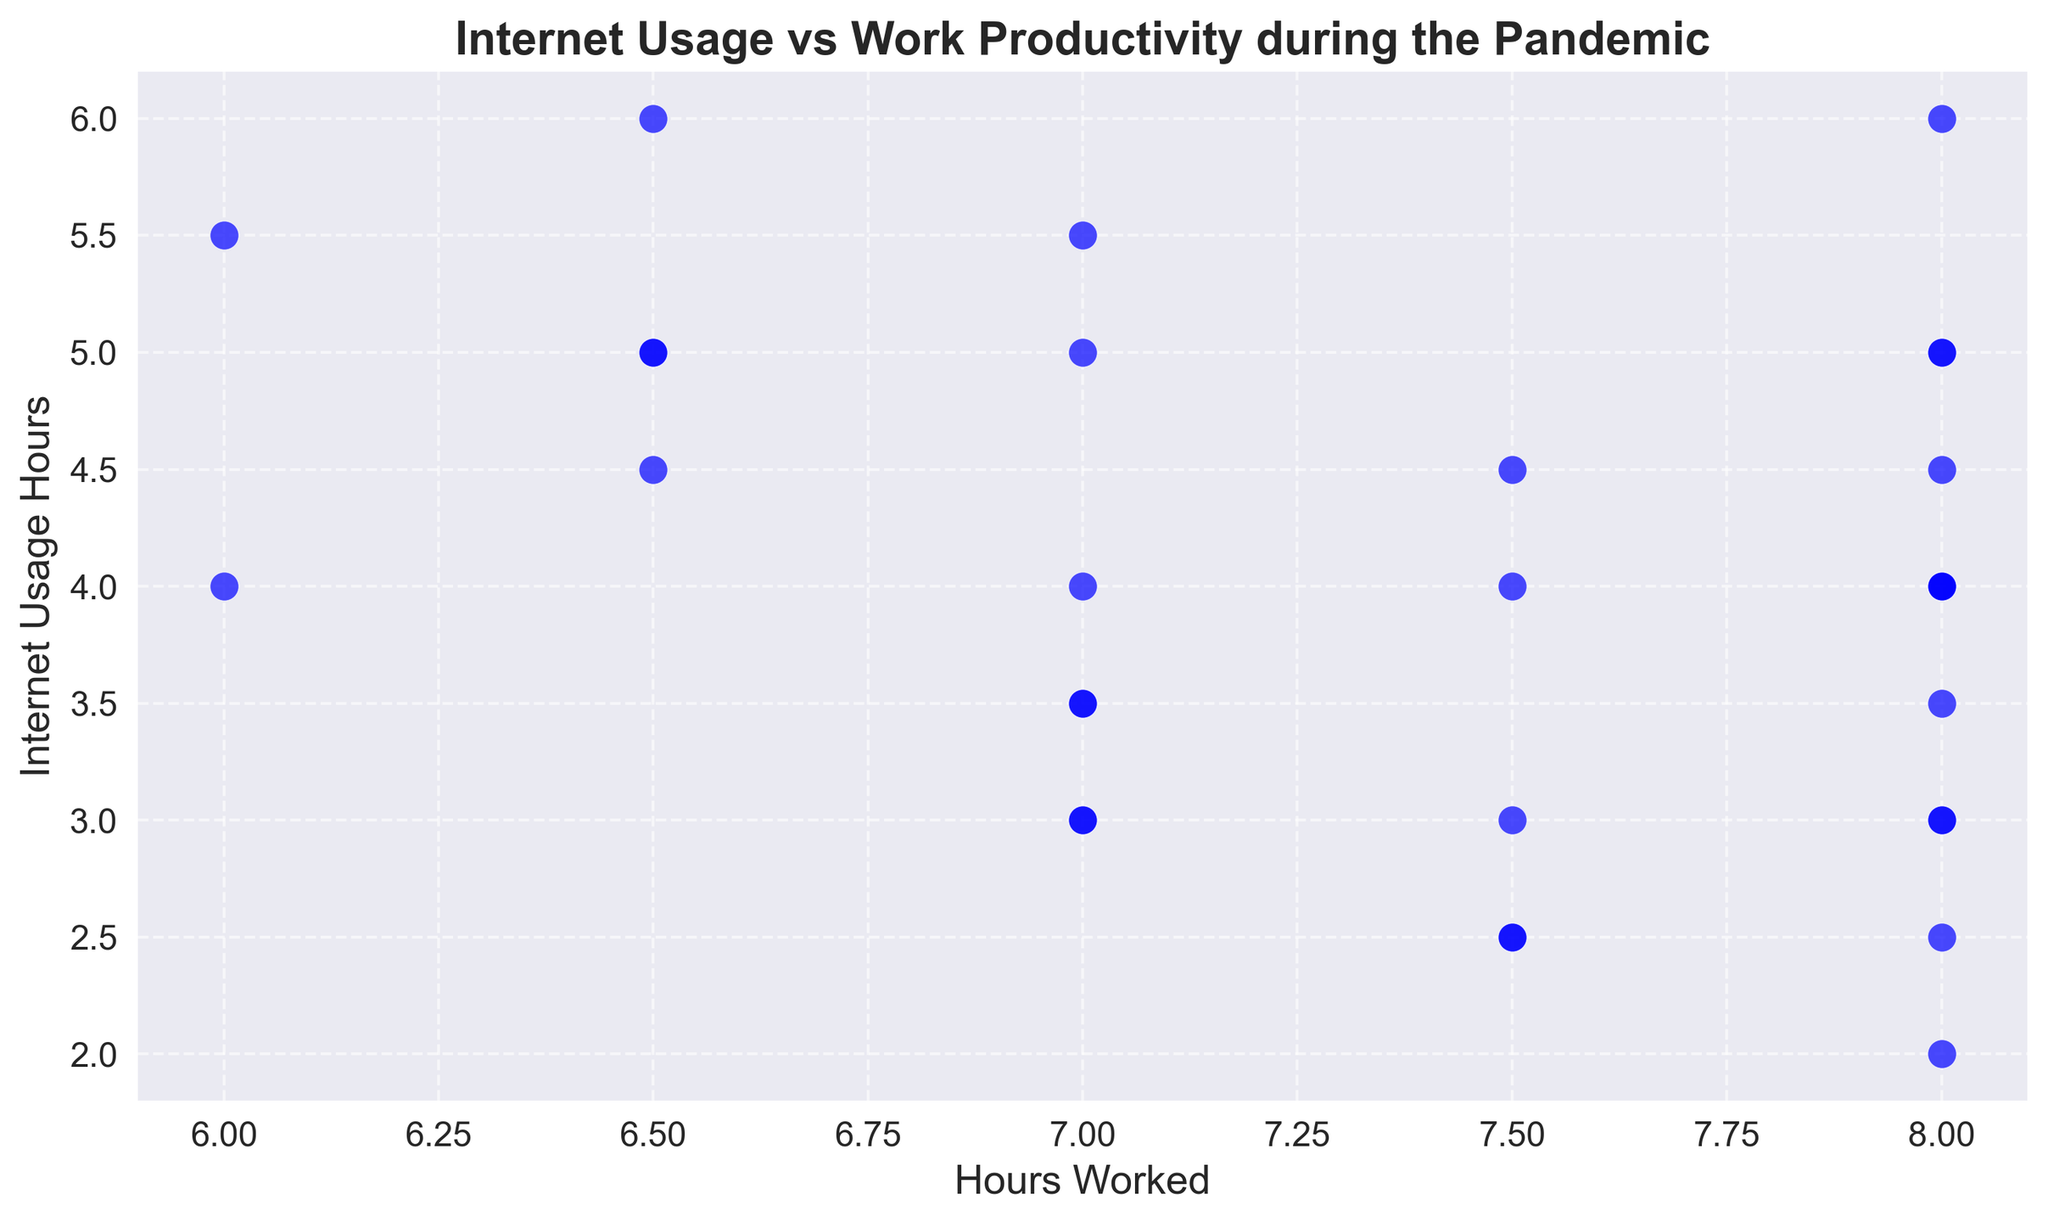What's the range of hours worked in the data? The range is calculated by taking the difference between the maximum and minimum values for 'Hours Worked'. The maximum hours worked is 8 and the minimum is 6.
Answer: 2 Does there seem to be a correlation between hours worked and internet usage? By visually inspecting the scatter plot, if points trend towards a line or curve, a correlation may be present. The plot has points scattered without a clear linear pattern, indicating a weak or no correlation.
Answer: Weak/No correlation What is the most common amount of daily internet usage? By looking for the most frequently occurring 'Internet Usage Hours' on the y-axis, we can spot that values around 3 and 4 appear quite often.
Answer: 3 and 4 Compare the internet usage between days with 8 hours worked and 7 hours worked. Identify the points with 'Hours Worked' of 8 and 7. For 8 hours worked, internet usage ranges from 2 to 6 hours. For 7 hours, it ranges from 2.5 to 5.5 hours, indicating broader variability.
Answer: 8 hours: 2-6, 7 hours: 2.5-5.5 What is the average internet usage on days with 7.5 hours of work? Locate the points with 7.5 hours worked and find the 'Internet Usage Hours' values (2.5, 4.5, 3, 4). The average is (2.5 + 4.5 + 3 + 4) / 4 = 3.5 hours.
Answer: 3.5 hours 